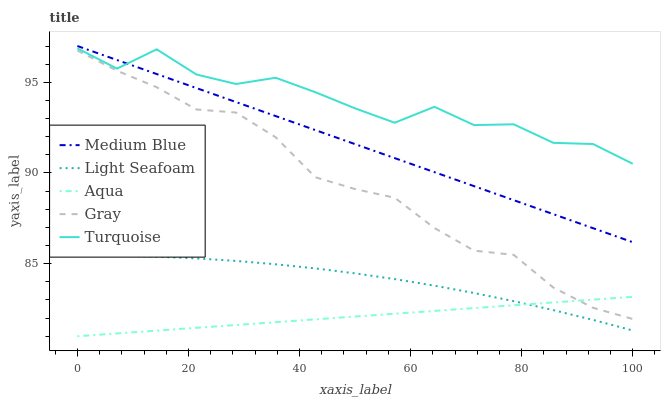Does Light Seafoam have the minimum area under the curve?
Answer yes or no. No. Does Light Seafoam have the maximum area under the curve?
Answer yes or no. No. Is Light Seafoam the smoothest?
Answer yes or no. No. Is Light Seafoam the roughest?
Answer yes or no. No. Does Light Seafoam have the lowest value?
Answer yes or no. No. Does Turquoise have the highest value?
Answer yes or no. No. Is Light Seafoam less than Turquoise?
Answer yes or no. Yes. Is Turquoise greater than Aqua?
Answer yes or no. Yes. Does Light Seafoam intersect Turquoise?
Answer yes or no. No. 